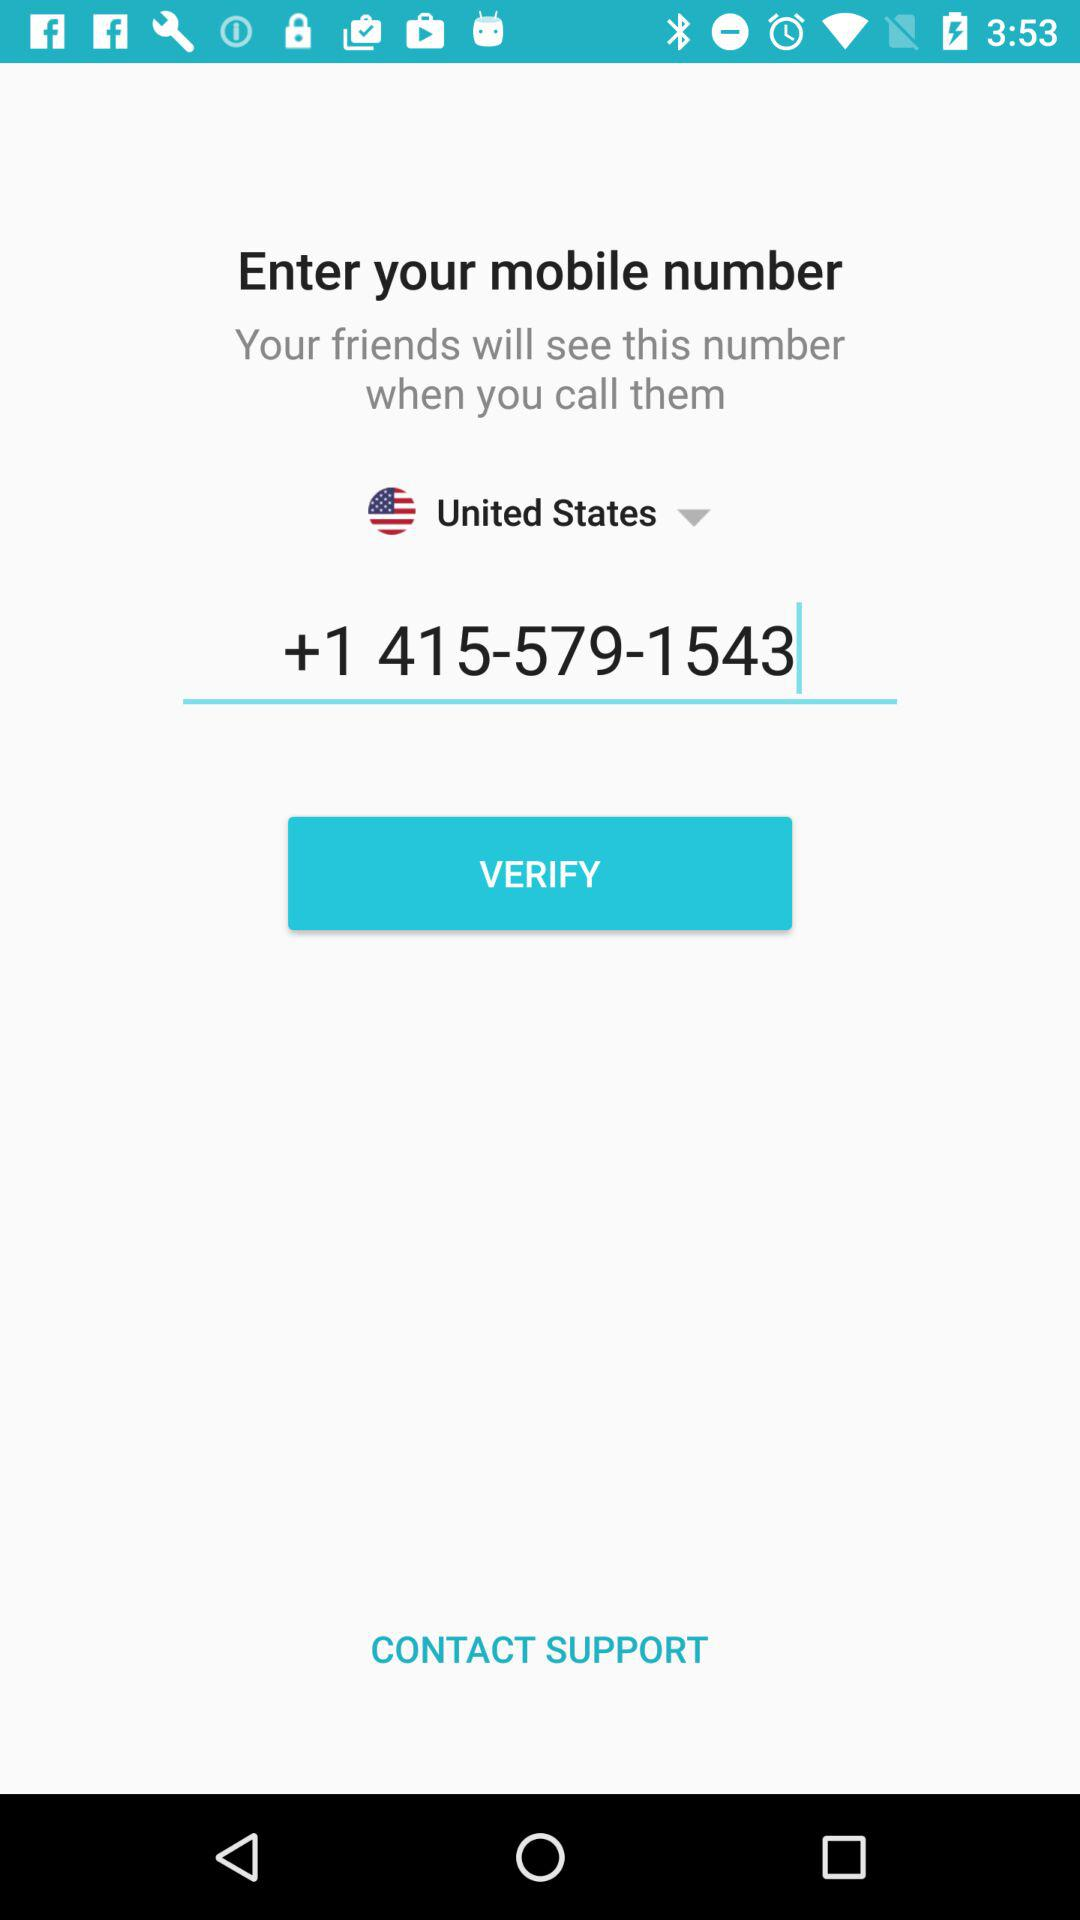What mobile number is entered? The entered mobile number is +1 415-579-1543. 